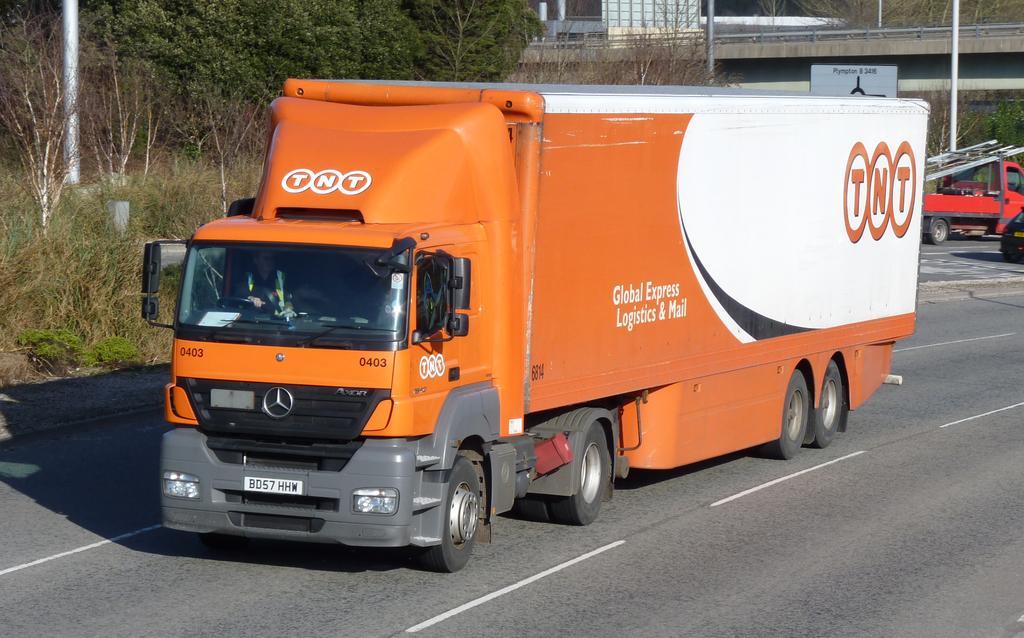How would you summarize this image in a sentence or two? In this image, we can see vehicles on the road and in the background, there are trees, poles and there is a bridge and a board. 